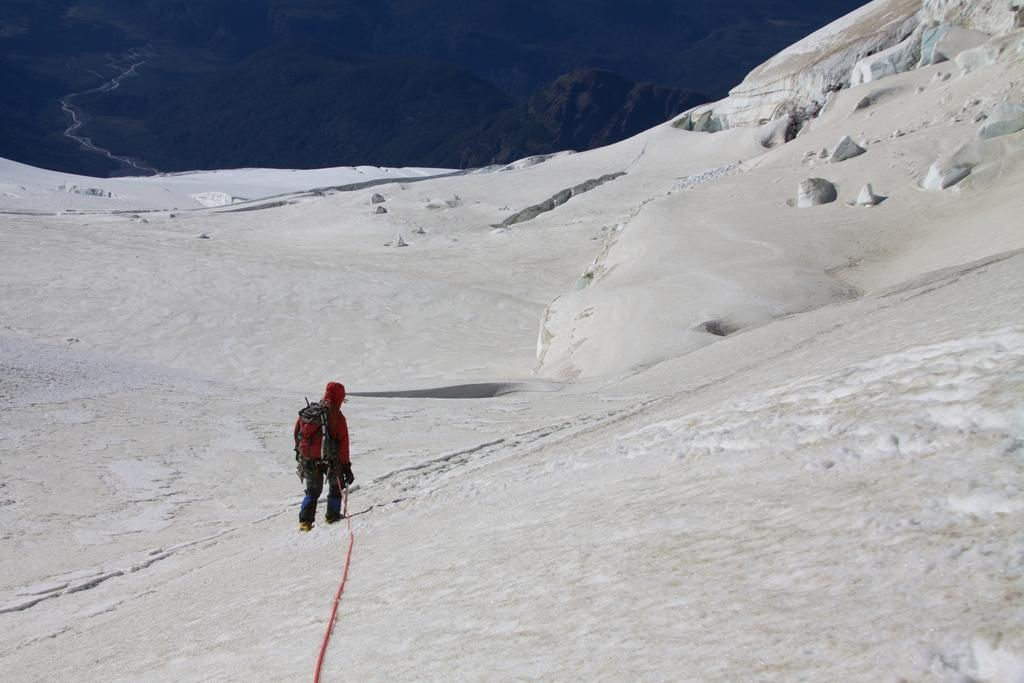What is the main subject of the image? There is a person standing in the center of the image. What is the person wearing? The person is wearing a backpack. What can be seen in the background of the image? There is snow visible in the background of the image. What heat source can be seen in the image? There is no heat source visible in the image. What discovery was made by the person in the image? The image does not provide any information about a discovery made by the person. 